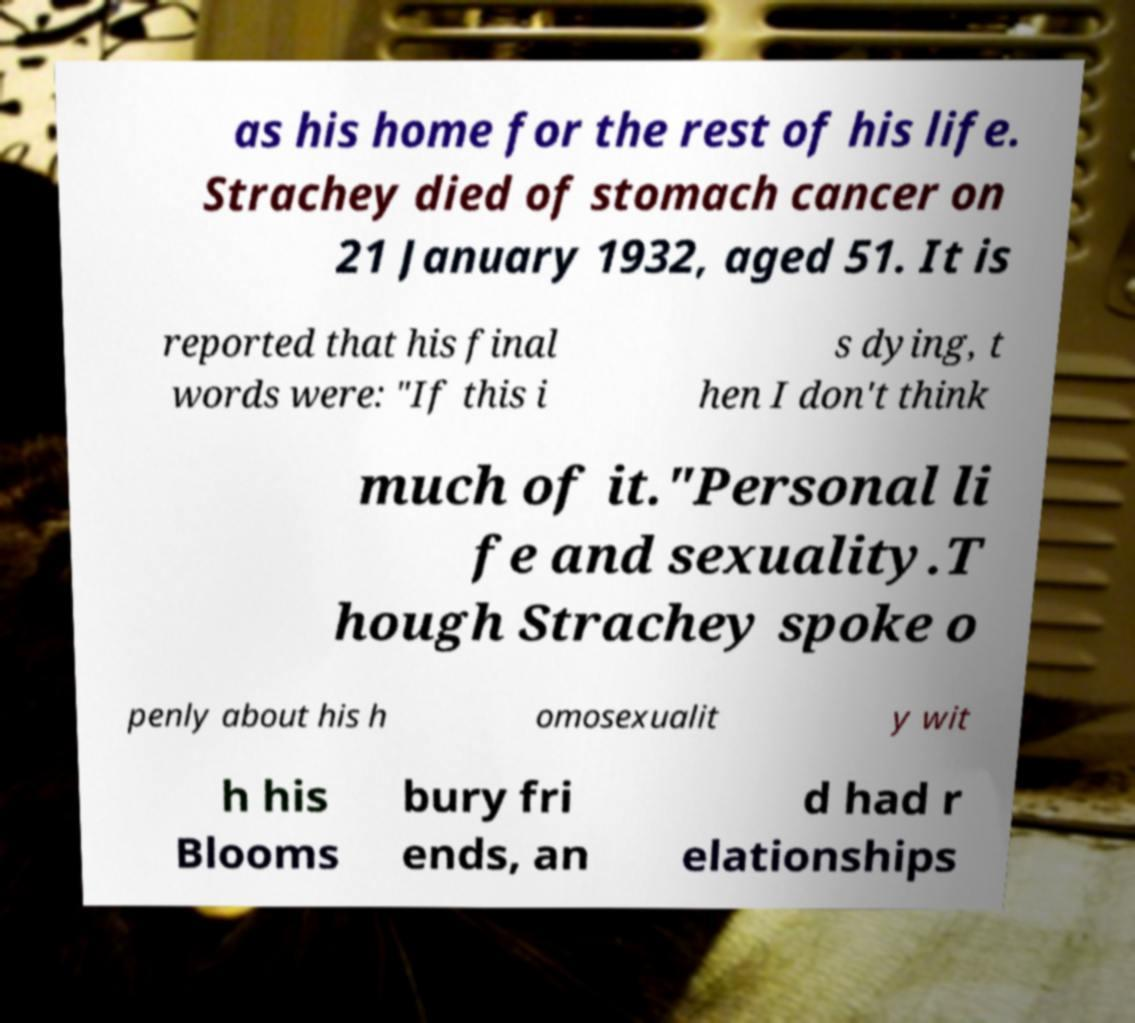Can you read and provide the text displayed in the image?This photo seems to have some interesting text. Can you extract and type it out for me? as his home for the rest of his life. Strachey died of stomach cancer on 21 January 1932, aged 51. It is reported that his final words were: "If this i s dying, t hen I don't think much of it."Personal li fe and sexuality.T hough Strachey spoke o penly about his h omosexualit y wit h his Blooms bury fri ends, an d had r elationships 